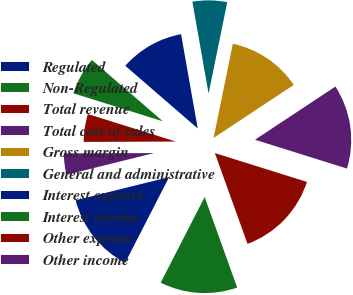<chart> <loc_0><loc_0><loc_500><loc_500><pie_chart><fcel>Regulated<fcel>Non-Regulated<fcel>Total revenue<fcel>Total cost of sales<fcel>Gross margin<fcel>General and administrative<fcel>Interest expense<fcel>Interest income<fcel>Other expense<fcel>Other income<nl><fcel>13.59%<fcel>13.04%<fcel>14.67%<fcel>14.13%<fcel>12.5%<fcel>5.98%<fcel>10.87%<fcel>6.52%<fcel>4.89%<fcel>3.8%<nl></chart> 